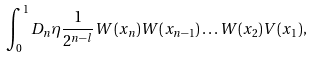<formula> <loc_0><loc_0><loc_500><loc_500>\int _ { 0 } ^ { 1 } D _ { n } \eta \frac { 1 } { 2 ^ { n - l } } W ( x _ { n } ) W ( x _ { n - 1 } ) \dots W ( x _ { 2 } ) V ( x _ { 1 } ) ,</formula> 